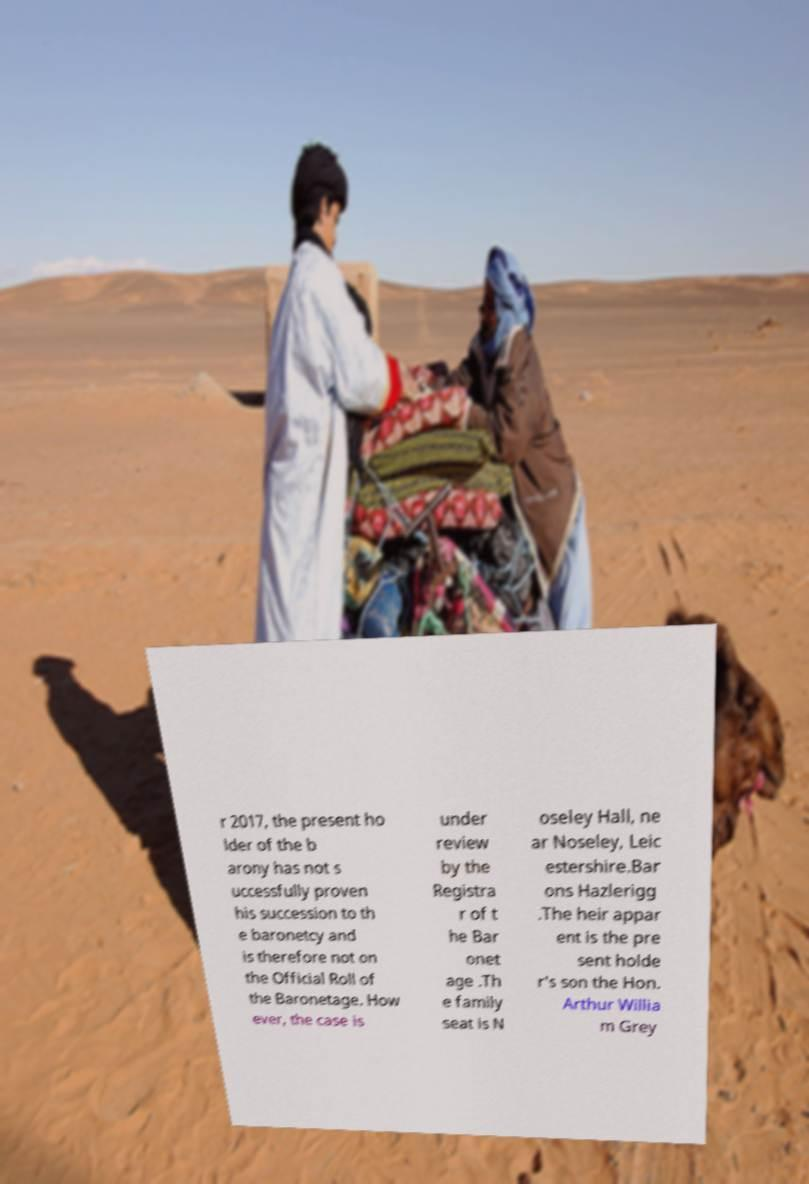I need the written content from this picture converted into text. Can you do that? r 2017, the present ho lder of the b arony has not s uccessfully proven his succession to th e baronetcy and is therefore not on the Official Roll of the Baronetage. How ever, the case is under review by the Registra r of t he Bar onet age .Th e family seat is N oseley Hall, ne ar Noseley, Leic estershire.Bar ons Hazlerigg .The heir appar ent is the pre sent holde r's son the Hon. Arthur Willia m Grey 